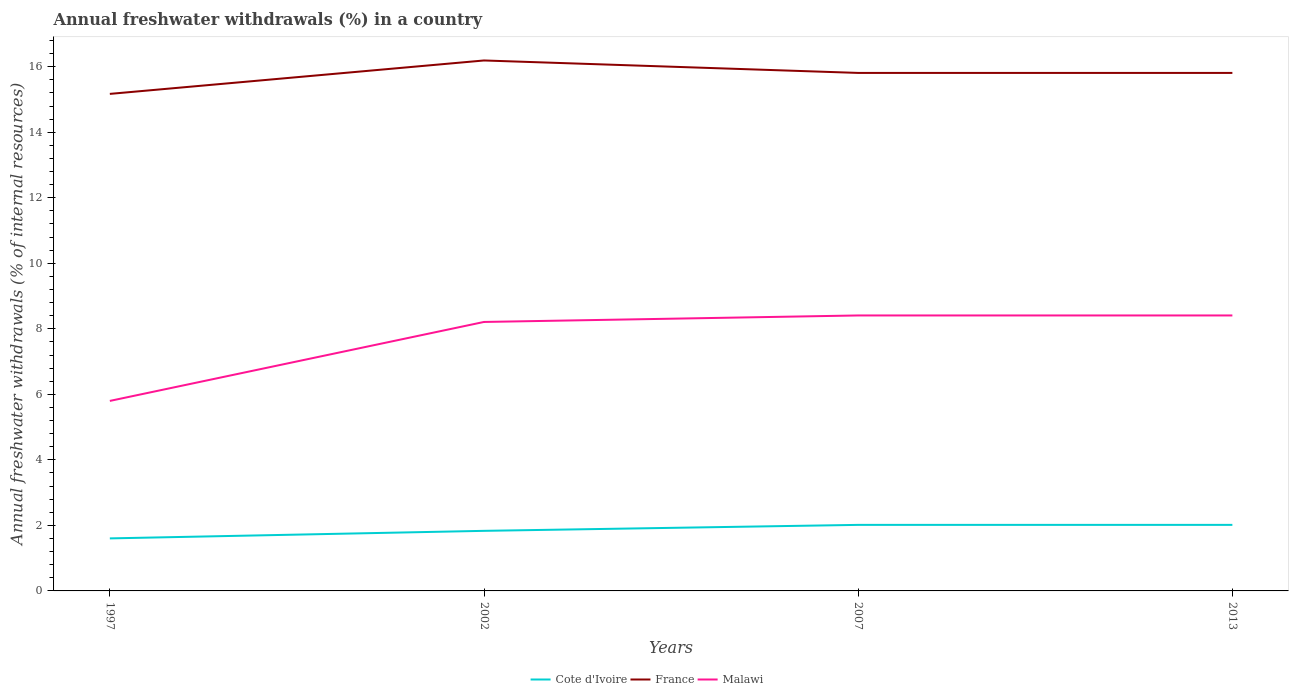How many different coloured lines are there?
Keep it short and to the point. 3. Is the number of lines equal to the number of legend labels?
Your answer should be very brief. Yes. Across all years, what is the maximum percentage of annual freshwater withdrawals in Malawi?
Ensure brevity in your answer.  5.8. In which year was the percentage of annual freshwater withdrawals in Cote d'Ivoire maximum?
Provide a short and direct response. 1997. What is the total percentage of annual freshwater withdrawals in Cote d'Ivoire in the graph?
Your answer should be compact. -0.41. What is the difference between the highest and the second highest percentage of annual freshwater withdrawals in Cote d'Ivoire?
Your answer should be very brief. 0.41. What is the difference between two consecutive major ticks on the Y-axis?
Offer a terse response. 2. Are the values on the major ticks of Y-axis written in scientific E-notation?
Offer a terse response. No. Where does the legend appear in the graph?
Your response must be concise. Bottom center. How many legend labels are there?
Your response must be concise. 3. What is the title of the graph?
Your answer should be compact. Annual freshwater withdrawals (%) in a country. Does "Hong Kong" appear as one of the legend labels in the graph?
Offer a very short reply. No. What is the label or title of the Y-axis?
Your answer should be very brief. Annual freshwater withdrawals (% of internal resources). What is the Annual freshwater withdrawals (% of internal resources) of Cote d'Ivoire in 1997?
Offer a very short reply. 1.6. What is the Annual freshwater withdrawals (% of internal resources) of France in 1997?
Your response must be concise. 15.17. What is the Annual freshwater withdrawals (% of internal resources) of Malawi in 1997?
Give a very brief answer. 5.8. What is the Annual freshwater withdrawals (% of internal resources) of Cote d'Ivoire in 2002?
Offer a very short reply. 1.83. What is the Annual freshwater withdrawals (% of internal resources) in France in 2002?
Offer a very short reply. 16.19. What is the Annual freshwater withdrawals (% of internal resources) of Malawi in 2002?
Give a very brief answer. 8.21. What is the Annual freshwater withdrawals (% of internal resources) of Cote d'Ivoire in 2007?
Provide a short and direct response. 2.02. What is the Annual freshwater withdrawals (% of internal resources) in France in 2007?
Give a very brief answer. 15.81. What is the Annual freshwater withdrawals (% of internal resources) of Malawi in 2007?
Your response must be concise. 8.41. What is the Annual freshwater withdrawals (% of internal resources) of Cote d'Ivoire in 2013?
Provide a succinct answer. 2.02. What is the Annual freshwater withdrawals (% of internal resources) in France in 2013?
Your response must be concise. 15.81. What is the Annual freshwater withdrawals (% of internal resources) of Malawi in 2013?
Offer a terse response. 8.41. Across all years, what is the maximum Annual freshwater withdrawals (% of internal resources) of Cote d'Ivoire?
Provide a short and direct response. 2.02. Across all years, what is the maximum Annual freshwater withdrawals (% of internal resources) of France?
Your response must be concise. 16.19. Across all years, what is the maximum Annual freshwater withdrawals (% of internal resources) in Malawi?
Your answer should be very brief. 8.41. Across all years, what is the minimum Annual freshwater withdrawals (% of internal resources) in Cote d'Ivoire?
Make the answer very short. 1.6. Across all years, what is the minimum Annual freshwater withdrawals (% of internal resources) in France?
Offer a terse response. 15.17. Across all years, what is the minimum Annual freshwater withdrawals (% of internal resources) of Malawi?
Your answer should be very brief. 5.8. What is the total Annual freshwater withdrawals (% of internal resources) in Cote d'Ivoire in the graph?
Your answer should be compact. 7.47. What is the total Annual freshwater withdrawals (% of internal resources) in France in the graph?
Provide a short and direct response. 62.98. What is the total Annual freshwater withdrawals (% of internal resources) in Malawi in the graph?
Your response must be concise. 30.82. What is the difference between the Annual freshwater withdrawals (% of internal resources) in Cote d'Ivoire in 1997 and that in 2002?
Keep it short and to the point. -0.23. What is the difference between the Annual freshwater withdrawals (% of internal resources) of France in 1997 and that in 2002?
Offer a terse response. -1.02. What is the difference between the Annual freshwater withdrawals (% of internal resources) in Malawi in 1997 and that in 2002?
Make the answer very short. -2.41. What is the difference between the Annual freshwater withdrawals (% of internal resources) of Cote d'Ivoire in 1997 and that in 2007?
Offer a terse response. -0.41. What is the difference between the Annual freshwater withdrawals (% of internal resources) in France in 1997 and that in 2007?
Offer a very short reply. -0.64. What is the difference between the Annual freshwater withdrawals (% of internal resources) in Malawi in 1997 and that in 2007?
Provide a short and direct response. -2.61. What is the difference between the Annual freshwater withdrawals (% of internal resources) in Cote d'Ivoire in 1997 and that in 2013?
Your answer should be very brief. -0.41. What is the difference between the Annual freshwater withdrawals (% of internal resources) of France in 1997 and that in 2013?
Keep it short and to the point. -0.64. What is the difference between the Annual freshwater withdrawals (% of internal resources) in Malawi in 1997 and that in 2013?
Provide a short and direct response. -2.61. What is the difference between the Annual freshwater withdrawals (% of internal resources) in Cote d'Ivoire in 2002 and that in 2007?
Keep it short and to the point. -0.18. What is the difference between the Annual freshwater withdrawals (% of internal resources) of France in 2002 and that in 2007?
Ensure brevity in your answer.  0.38. What is the difference between the Annual freshwater withdrawals (% of internal resources) of Malawi in 2002 and that in 2007?
Make the answer very short. -0.2. What is the difference between the Annual freshwater withdrawals (% of internal resources) in Cote d'Ivoire in 2002 and that in 2013?
Your answer should be very brief. -0.18. What is the difference between the Annual freshwater withdrawals (% of internal resources) in France in 2002 and that in 2013?
Make the answer very short. 0.38. What is the difference between the Annual freshwater withdrawals (% of internal resources) of Malawi in 2002 and that in 2013?
Give a very brief answer. -0.2. What is the difference between the Annual freshwater withdrawals (% of internal resources) in Cote d'Ivoire in 1997 and the Annual freshwater withdrawals (% of internal resources) in France in 2002?
Make the answer very short. -14.59. What is the difference between the Annual freshwater withdrawals (% of internal resources) of Cote d'Ivoire in 1997 and the Annual freshwater withdrawals (% of internal resources) of Malawi in 2002?
Make the answer very short. -6.61. What is the difference between the Annual freshwater withdrawals (% of internal resources) of France in 1997 and the Annual freshwater withdrawals (% of internal resources) of Malawi in 2002?
Keep it short and to the point. 6.96. What is the difference between the Annual freshwater withdrawals (% of internal resources) in Cote d'Ivoire in 1997 and the Annual freshwater withdrawals (% of internal resources) in France in 2007?
Keep it short and to the point. -14.21. What is the difference between the Annual freshwater withdrawals (% of internal resources) of Cote d'Ivoire in 1997 and the Annual freshwater withdrawals (% of internal resources) of Malawi in 2007?
Your response must be concise. -6.8. What is the difference between the Annual freshwater withdrawals (% of internal resources) of France in 1997 and the Annual freshwater withdrawals (% of internal resources) of Malawi in 2007?
Make the answer very short. 6.76. What is the difference between the Annual freshwater withdrawals (% of internal resources) in Cote d'Ivoire in 1997 and the Annual freshwater withdrawals (% of internal resources) in France in 2013?
Make the answer very short. -14.21. What is the difference between the Annual freshwater withdrawals (% of internal resources) of Cote d'Ivoire in 1997 and the Annual freshwater withdrawals (% of internal resources) of Malawi in 2013?
Give a very brief answer. -6.8. What is the difference between the Annual freshwater withdrawals (% of internal resources) in France in 1997 and the Annual freshwater withdrawals (% of internal resources) in Malawi in 2013?
Your answer should be very brief. 6.76. What is the difference between the Annual freshwater withdrawals (% of internal resources) of Cote d'Ivoire in 2002 and the Annual freshwater withdrawals (% of internal resources) of France in 2007?
Your response must be concise. -13.98. What is the difference between the Annual freshwater withdrawals (% of internal resources) of Cote d'Ivoire in 2002 and the Annual freshwater withdrawals (% of internal resources) of Malawi in 2007?
Your answer should be compact. -6.57. What is the difference between the Annual freshwater withdrawals (% of internal resources) of France in 2002 and the Annual freshwater withdrawals (% of internal resources) of Malawi in 2007?
Your answer should be compact. 7.78. What is the difference between the Annual freshwater withdrawals (% of internal resources) in Cote d'Ivoire in 2002 and the Annual freshwater withdrawals (% of internal resources) in France in 2013?
Give a very brief answer. -13.98. What is the difference between the Annual freshwater withdrawals (% of internal resources) in Cote d'Ivoire in 2002 and the Annual freshwater withdrawals (% of internal resources) in Malawi in 2013?
Your response must be concise. -6.57. What is the difference between the Annual freshwater withdrawals (% of internal resources) of France in 2002 and the Annual freshwater withdrawals (% of internal resources) of Malawi in 2013?
Your response must be concise. 7.78. What is the difference between the Annual freshwater withdrawals (% of internal resources) of Cote d'Ivoire in 2007 and the Annual freshwater withdrawals (% of internal resources) of France in 2013?
Give a very brief answer. -13.79. What is the difference between the Annual freshwater withdrawals (% of internal resources) of Cote d'Ivoire in 2007 and the Annual freshwater withdrawals (% of internal resources) of Malawi in 2013?
Provide a short and direct response. -6.39. What is the difference between the Annual freshwater withdrawals (% of internal resources) in France in 2007 and the Annual freshwater withdrawals (% of internal resources) in Malawi in 2013?
Your answer should be compact. 7.4. What is the average Annual freshwater withdrawals (% of internal resources) in Cote d'Ivoire per year?
Provide a short and direct response. 1.87. What is the average Annual freshwater withdrawals (% of internal resources) of France per year?
Your answer should be compact. 15.74. What is the average Annual freshwater withdrawals (% of internal resources) in Malawi per year?
Give a very brief answer. 7.71. In the year 1997, what is the difference between the Annual freshwater withdrawals (% of internal resources) in Cote d'Ivoire and Annual freshwater withdrawals (% of internal resources) in France?
Keep it short and to the point. -13.57. In the year 1997, what is the difference between the Annual freshwater withdrawals (% of internal resources) of Cote d'Ivoire and Annual freshwater withdrawals (% of internal resources) of Malawi?
Your response must be concise. -4.2. In the year 1997, what is the difference between the Annual freshwater withdrawals (% of internal resources) in France and Annual freshwater withdrawals (% of internal resources) in Malawi?
Your response must be concise. 9.37. In the year 2002, what is the difference between the Annual freshwater withdrawals (% of internal resources) of Cote d'Ivoire and Annual freshwater withdrawals (% of internal resources) of France?
Offer a very short reply. -14.36. In the year 2002, what is the difference between the Annual freshwater withdrawals (% of internal resources) of Cote d'Ivoire and Annual freshwater withdrawals (% of internal resources) of Malawi?
Offer a very short reply. -6.38. In the year 2002, what is the difference between the Annual freshwater withdrawals (% of internal resources) in France and Annual freshwater withdrawals (% of internal resources) in Malawi?
Your answer should be compact. 7.98. In the year 2007, what is the difference between the Annual freshwater withdrawals (% of internal resources) of Cote d'Ivoire and Annual freshwater withdrawals (% of internal resources) of France?
Provide a short and direct response. -13.79. In the year 2007, what is the difference between the Annual freshwater withdrawals (% of internal resources) of Cote d'Ivoire and Annual freshwater withdrawals (% of internal resources) of Malawi?
Ensure brevity in your answer.  -6.39. In the year 2007, what is the difference between the Annual freshwater withdrawals (% of internal resources) in France and Annual freshwater withdrawals (% of internal resources) in Malawi?
Ensure brevity in your answer.  7.4. In the year 2013, what is the difference between the Annual freshwater withdrawals (% of internal resources) of Cote d'Ivoire and Annual freshwater withdrawals (% of internal resources) of France?
Your response must be concise. -13.79. In the year 2013, what is the difference between the Annual freshwater withdrawals (% of internal resources) of Cote d'Ivoire and Annual freshwater withdrawals (% of internal resources) of Malawi?
Keep it short and to the point. -6.39. In the year 2013, what is the difference between the Annual freshwater withdrawals (% of internal resources) of France and Annual freshwater withdrawals (% of internal resources) of Malawi?
Your response must be concise. 7.4. What is the ratio of the Annual freshwater withdrawals (% of internal resources) of Cote d'Ivoire in 1997 to that in 2002?
Keep it short and to the point. 0.87. What is the ratio of the Annual freshwater withdrawals (% of internal resources) of France in 1997 to that in 2002?
Your answer should be very brief. 0.94. What is the ratio of the Annual freshwater withdrawals (% of internal resources) in Malawi in 1997 to that in 2002?
Your answer should be very brief. 0.71. What is the ratio of the Annual freshwater withdrawals (% of internal resources) in Cote d'Ivoire in 1997 to that in 2007?
Your answer should be very brief. 0.8. What is the ratio of the Annual freshwater withdrawals (% of internal resources) in France in 1997 to that in 2007?
Offer a very short reply. 0.96. What is the ratio of the Annual freshwater withdrawals (% of internal resources) of Malawi in 1997 to that in 2007?
Ensure brevity in your answer.  0.69. What is the ratio of the Annual freshwater withdrawals (% of internal resources) of Cote d'Ivoire in 1997 to that in 2013?
Provide a succinct answer. 0.8. What is the ratio of the Annual freshwater withdrawals (% of internal resources) in France in 1997 to that in 2013?
Offer a terse response. 0.96. What is the ratio of the Annual freshwater withdrawals (% of internal resources) of Malawi in 1997 to that in 2013?
Provide a succinct answer. 0.69. What is the ratio of the Annual freshwater withdrawals (% of internal resources) of Cote d'Ivoire in 2002 to that in 2007?
Your answer should be compact. 0.91. What is the ratio of the Annual freshwater withdrawals (% of internal resources) in Malawi in 2002 to that in 2007?
Keep it short and to the point. 0.98. What is the ratio of the Annual freshwater withdrawals (% of internal resources) in Cote d'Ivoire in 2002 to that in 2013?
Give a very brief answer. 0.91. What is the ratio of the Annual freshwater withdrawals (% of internal resources) of France in 2002 to that in 2013?
Your answer should be very brief. 1.02. What is the ratio of the Annual freshwater withdrawals (% of internal resources) of Malawi in 2002 to that in 2013?
Your answer should be very brief. 0.98. What is the ratio of the Annual freshwater withdrawals (% of internal resources) of France in 2007 to that in 2013?
Provide a succinct answer. 1. What is the ratio of the Annual freshwater withdrawals (% of internal resources) of Malawi in 2007 to that in 2013?
Provide a succinct answer. 1. What is the difference between the highest and the second highest Annual freshwater withdrawals (% of internal resources) in France?
Give a very brief answer. 0.38. What is the difference between the highest and the second highest Annual freshwater withdrawals (% of internal resources) in Malawi?
Ensure brevity in your answer.  0. What is the difference between the highest and the lowest Annual freshwater withdrawals (% of internal resources) of Cote d'Ivoire?
Give a very brief answer. 0.41. What is the difference between the highest and the lowest Annual freshwater withdrawals (% of internal resources) in France?
Offer a terse response. 1.02. What is the difference between the highest and the lowest Annual freshwater withdrawals (% of internal resources) of Malawi?
Offer a very short reply. 2.61. 